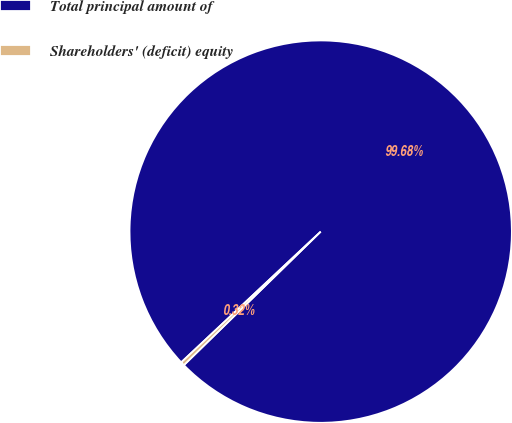<chart> <loc_0><loc_0><loc_500><loc_500><pie_chart><fcel>Total principal amount of<fcel>Shareholders' (deficit) equity<nl><fcel>99.68%<fcel>0.32%<nl></chart> 